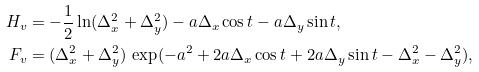<formula> <loc_0><loc_0><loc_500><loc_500>H _ { v } & = - \frac { 1 } { 2 } \ln ( \Delta _ { x } ^ { 2 } + \Delta _ { y } ^ { 2 } ) - a \Delta _ { x } \cos t - a \Delta _ { y } \sin t , \\ F _ { v } & = ( \Delta _ { x } ^ { 2 } + \Delta _ { y } ^ { 2 } ) \, \exp ( - a ^ { 2 } + 2 a \Delta _ { x } \cos t + 2 a \Delta _ { y } \sin t - \Delta _ { x } ^ { 2 } - \Delta _ { y } ^ { 2 } ) ,</formula> 